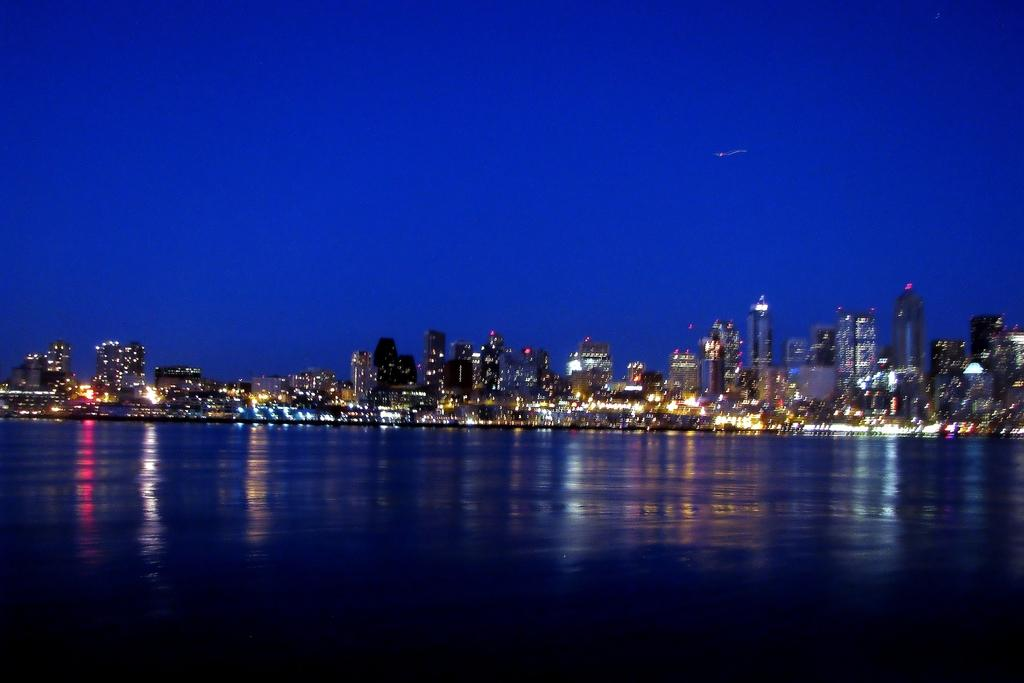What type of structures can be seen in the image? There are buildings in the image. What natural element is visible in the image? There is water visible in the image. What part of the natural environment is visible in the image? The sky is visible in the image. Where is the playground located in the image? There is no playground present in the image. What type of action is being performed by the bike in the image? There is no bike present in the image. 